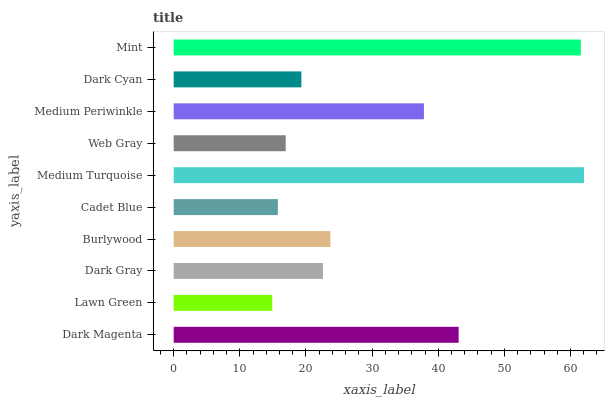Is Lawn Green the minimum?
Answer yes or no. Yes. Is Medium Turquoise the maximum?
Answer yes or no. Yes. Is Dark Gray the minimum?
Answer yes or no. No. Is Dark Gray the maximum?
Answer yes or no. No. Is Dark Gray greater than Lawn Green?
Answer yes or no. Yes. Is Lawn Green less than Dark Gray?
Answer yes or no. Yes. Is Lawn Green greater than Dark Gray?
Answer yes or no. No. Is Dark Gray less than Lawn Green?
Answer yes or no. No. Is Burlywood the high median?
Answer yes or no. Yes. Is Dark Gray the low median?
Answer yes or no. Yes. Is Dark Magenta the high median?
Answer yes or no. No. Is Cadet Blue the low median?
Answer yes or no. No. 